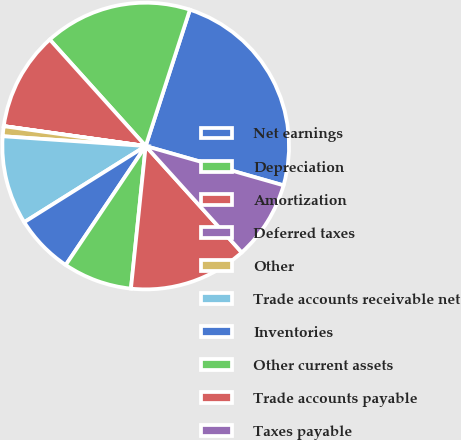Convert chart to OTSL. <chart><loc_0><loc_0><loc_500><loc_500><pie_chart><fcel>Net earnings<fcel>Depreciation<fcel>Amortization<fcel>Deferred taxes<fcel>Other<fcel>Trade accounts receivable net<fcel>Inventories<fcel>Other current assets<fcel>Trade accounts payable<fcel>Taxes payable<nl><fcel>24.43%<fcel>16.66%<fcel>11.11%<fcel>0.01%<fcel>1.12%<fcel>10.0%<fcel>6.67%<fcel>7.78%<fcel>13.33%<fcel>8.89%<nl></chart> 